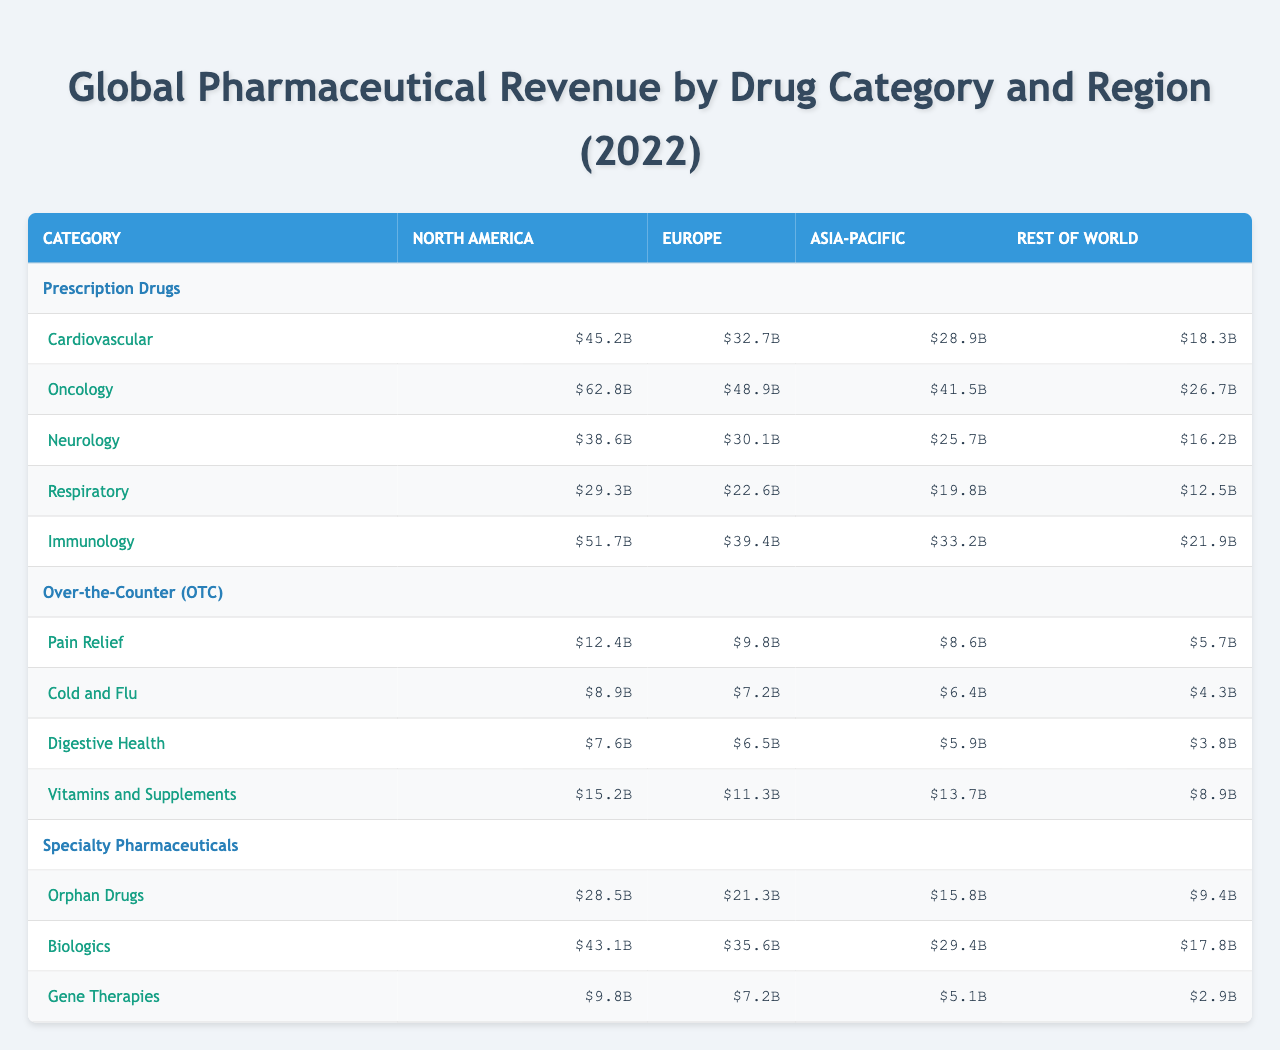What is the revenue from Oncology drugs in North America? The table shows the revenue from Oncology drugs under the Prescription Drugs category for North America, which is listed as $62.8 billion.
Answer: $62.8 billion Which region has the highest revenue for Immunology drugs? Looking at the Immunology drugs under Prescription Drugs across all regions, North America has the highest revenue at $51.7 billion, compared to Europe ($39.4 billion), Asia-Pacific ($33.2 billion), and Rest of World ($21.9 billion).
Answer: North America What is the total revenue from Pain Relief drugs across all regions? The revenue from Pain Relief drugs is as follows: North America: $12.4 billion, Europe: $9.8 billion, Asia-Pacific: $8.6 billion, Rest of World: $5.7 billion. Adding these gives $12.4 + $9.8 + $8.6 + $5.7 = $36.5 billion.
Answer: $36.5 billion In which category did the Asia-Pacific region have the lowest revenue? By comparing the revenues in the Asia-Pacific region under different categories, for Prescription Drugs, the lowest is Neurology at $25.7 billion, in Over-the-Counter (OTC) it is Digestive Health at $5.9 billion, and for Specialty Pharmaceuticals, it is Gene Therapies at $5.1 billion. Among these, the lowest overall is for Gene Therapies in Specialty Pharmaceuticals.
Answer: Specialty Pharmaceuticals (Gene Therapies) What is the average revenue from Orphan Drugs across all regions? The revenues from Orphan Drugs are: North America: $28.5 billion, Europe: $21.3 billion, Asia-Pacific: $15.8 billion, Rest of World: $9.4 billion. Summing them gives $28.5 + $21.3 + $15.8 + $9.4 = $75 billion. Dividing by 4 regions for the average: $75 billion / 4 = $18.75 billion.
Answer: $18.75 billion Is the revenue from OTC drugs higher in North America than in Europe? In North America, the total revenue from OTC drugs is $12.4 + $8.9 + $7.6 + $15.2 = $44.1 billion. In Europe, it is $9.8 + $7.2 + $6.5 + $11.3 = $34.8 billion. Since $44.1 billion is greater than $34.8 billion, the answer is yes.
Answer: Yes Which region has the highest combined revenue for Specialty Pharmaceuticals? The revenues for Specialty Pharmaceuticals are as follows: North America: $43.1 (Biologics) + $28.5 (Orphan Drugs) + $9.8 (Gene Therapies) = $81.4 billion, Europe: $35.6 + $21.3 + $7.2 = $64.1 billion, Asia-Pacific: $29.4 + $15.8 + $5.1 = $50.3 billion, Rest of World: $17.8 + $9.4 + $2.9 = $30.1 billion. The highest is $81.4 billion from North America.
Answer: North America What is the total revenue from all drug categories in Europe? To find the total in Europe, we need to sum the revenues from all categories: Prescription Drugs ($32.7 + $48.9 + $30.1 + $22.6 + $39.4) = $173.7 billion, OTC ($9.8 + $7.2 + $6.5 + $11.3) = $34.8 billion, Specialty Pharmaceuticals ($21.3 + $35.6 + $7.2) = $64.1 billion. So total = $173.7 + $34.8 + $64.1 = $272.6 billion.
Answer: $272.6 billion Is the revenue for Respiratory drugs higher than for Digestive Health in the Rest of World region? In the Rest of World, Respiratory drugs have a revenue of $12.5 billion, and Digestive Health has a revenue of $3.8 billion. Since $12.5 billion is greater than $3.8 billion, the answer is yes.
Answer: Yes What is the revenue difference for Cardiovascular drugs between North America and Rest of World? For North America, Cardiovascular drugs revenue is $45.2 billion, and for Rest of World, it is $18.3 billion. The difference is $45.2 - $18.3 = $26.9 billion.
Answer: $26.9 billion 